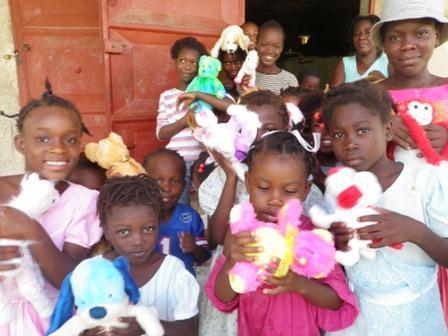How many teddy bears are in the picture?
Give a very brief answer. 3. How many people can you see?
Give a very brief answer. 10. 